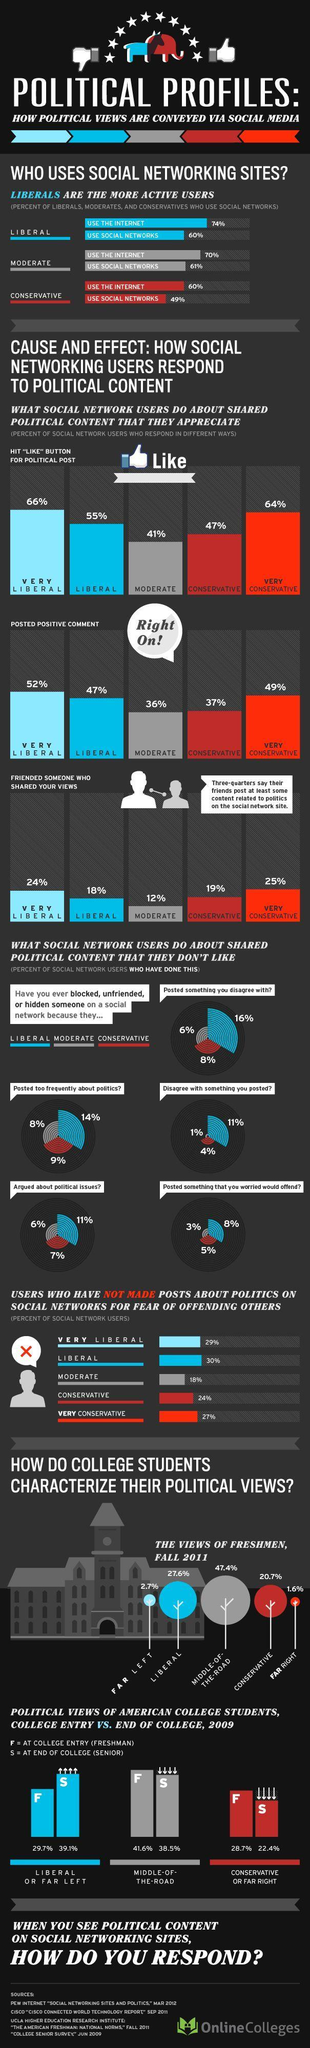Which group posted 37% of positive comment on social media?
Answer the question with a short phrase. CONSERVATIVE What percentage of Liberals had friends who shared their political views? 18% What percentage of college seniors have far left political ideology? 39.1% What percentage of people hit like button for moderate posts? 41% Which category of people have blocked or unfollowed the least percentage friends? MODERATE What percentage of college students have chosen the middle path of expressing political views? 47.4% What percentage decrease in seniors having far right political view from the time they joined college? 6.3% 